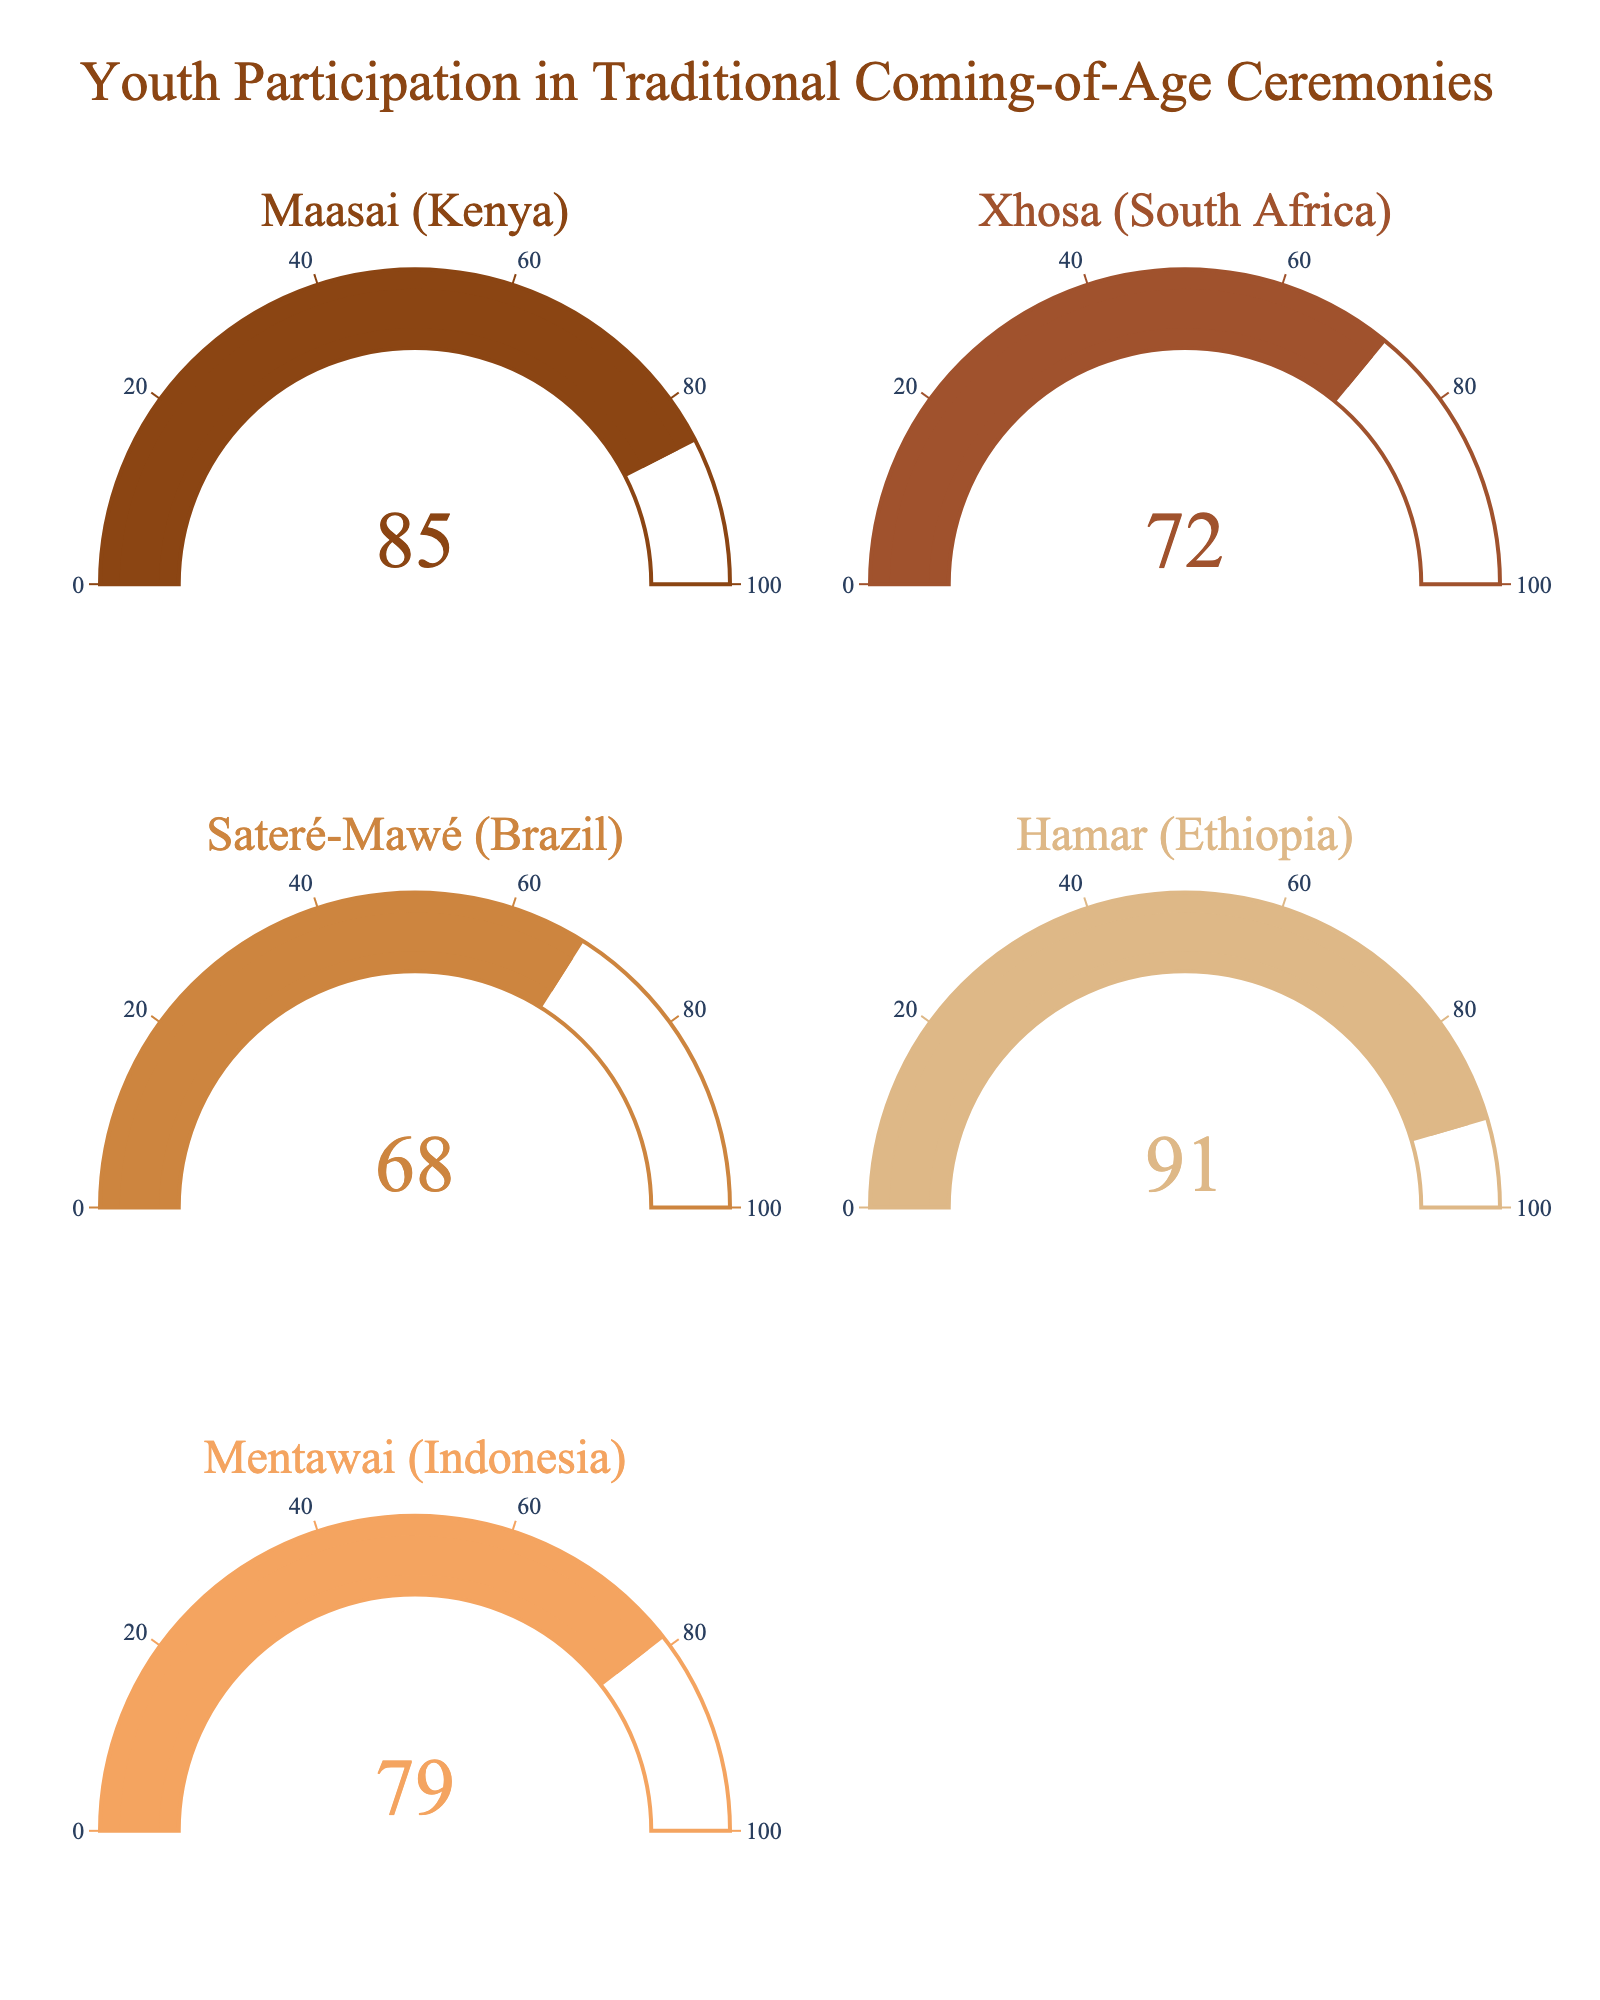what is the title of the chart? The title of the chart is usually displayed at the top. In this chart, it states "Youth Participation in Traditional Coming-of-Age Ceremonies".
Answer: Youth Participation in Traditional Coming-of-Age Ceremonies What is the percentage of youth participating in the Maasai coming-of-age ceremony? Look at the gauge labeled "Maasai (Kenya)" and note the percentage value.
Answer: 85 Which region has the highest youth participation rate in traditional coming-of-age ceremonies? Compare all the percentages displayed on the different gauges and identify the highest one. The region with this rate is Hamar (Ethiopia).
Answer: Hamar (Ethiopia) What is the difference in participation rates between the Xhosa and the Mentawai? To find the difference, subtract the lower percentage (Mentawai) from the higher percentage (Xhosa). Calculate 79 - 72.
Answer: 7 How many regions have a youth participation rate of above 80%? Count the number of gauges with percentages higher than 80%. Maasai (Kenya) and Hamar (Ethiopia) have rates above 80%.
Answer: 2 Considering all the regions displayed, what is the average percentage of youth participating in traditional ceremonies? Add up all the percentages and divide by the number of regions. (85 + 72 + 68 + 91 + 79) / 5 = 395 / 5
Answer: 79 In which region is the youth participation in traditional coming-of-age ceremonies lowest? Compare all the percentages on the gauges and identify the lowest one. Sateré-Mawé (Brazil) has the lowest participation rate.
Answer: Sateré-Mawé (Brazil) Arrange the regions in ascending order of youth participation in traditional ceremonies. List all the regions and their participation rates, then order them from the lowest to the highest percentages: Sateré-Mawé (Brazil) 68, Xhosa (South Africa) 72, Mentawai (Indonesia) 79, Maasai (Kenya) 85, Hamar (Ethiopia) 91.
Answer: Sateré-Mawé, Xhosa, Mentawai, Maasai, Hamar What is the median percentage of youth participating across the given regions? The median is the middle value when the percentages are ordered from lowest to highest. The ordered values are 68, 72, 79, 85, and 91. The middle value in this set is 79.
Answer: 79 